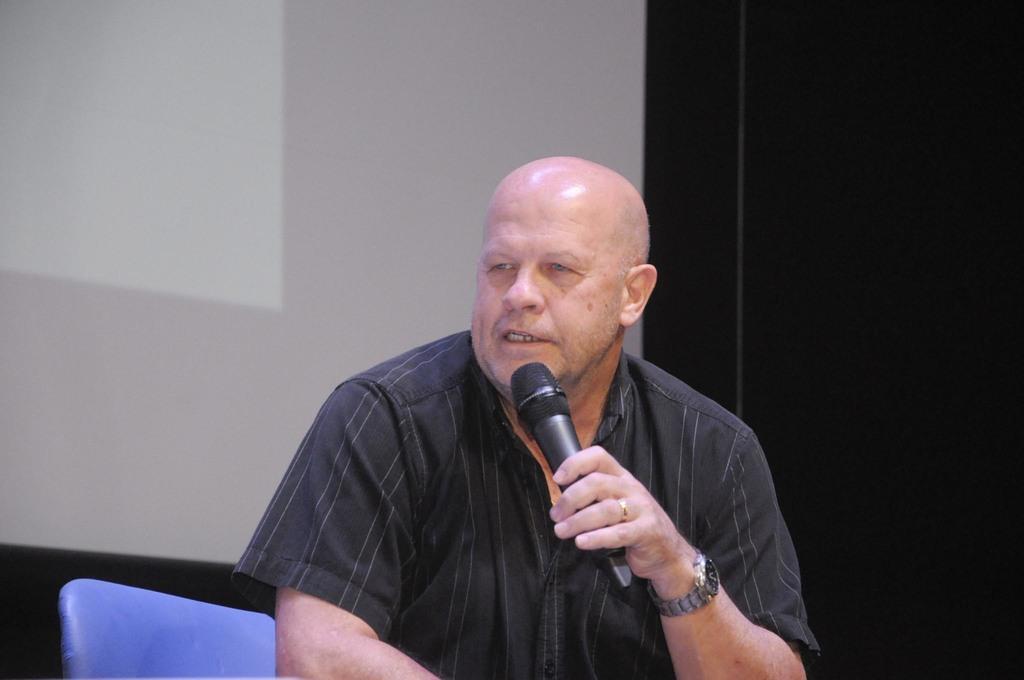How would you summarize this image in a sentence or two? In this image I can see a person holding the mic. In the background there is a screen. 